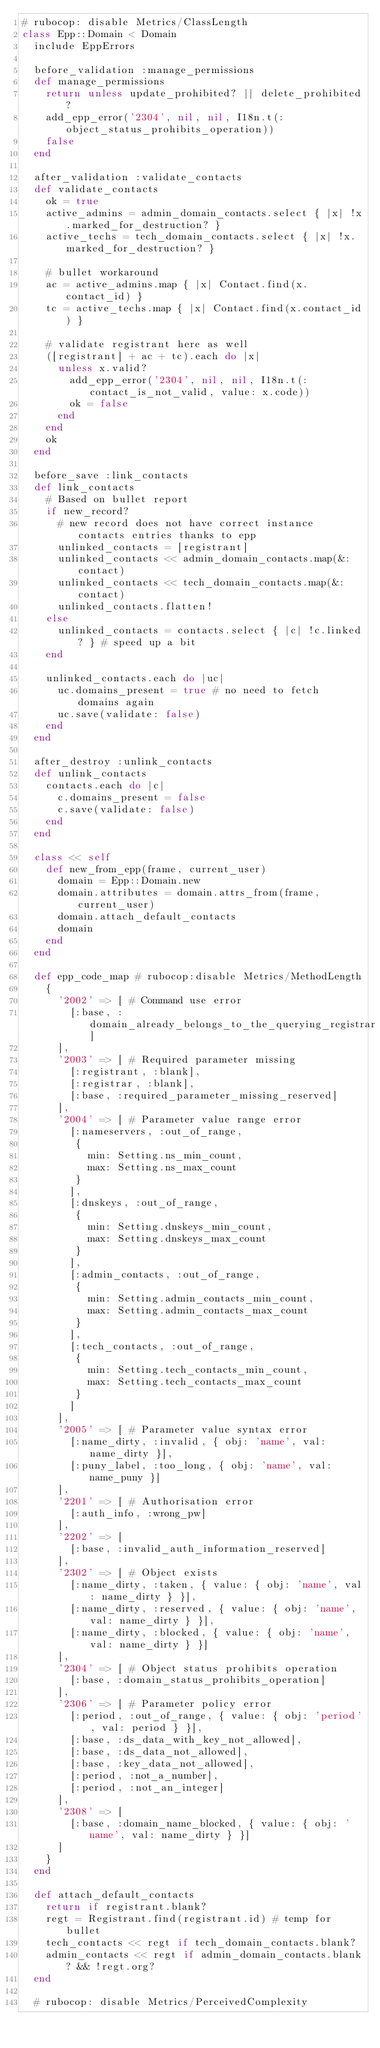Convert code to text. <code><loc_0><loc_0><loc_500><loc_500><_Ruby_># rubocop: disable Metrics/ClassLength
class Epp::Domain < Domain
  include EppErrors

  before_validation :manage_permissions
  def manage_permissions
    return unless update_prohibited? || delete_prohibited?
    add_epp_error('2304', nil, nil, I18n.t(:object_status_prohibits_operation))
    false
  end

  after_validation :validate_contacts
  def validate_contacts
    ok = true
    active_admins = admin_domain_contacts.select { |x| !x.marked_for_destruction? }
    active_techs = tech_domain_contacts.select { |x| !x.marked_for_destruction? }

    # bullet workaround
    ac = active_admins.map { |x| Contact.find(x.contact_id) }
    tc = active_techs.map { |x| Contact.find(x.contact_id) }

    # validate registrant here as well
    ([registrant] + ac + tc).each do |x|
      unless x.valid?
        add_epp_error('2304', nil, nil, I18n.t(:contact_is_not_valid, value: x.code))
        ok = false
      end
    end
    ok
  end

  before_save :link_contacts
  def link_contacts
    # Based on bullet report
    if new_record?
      # new record does not have correct instance contacts entries thanks to epp
      unlinked_contacts = [registrant]
      unlinked_contacts << admin_domain_contacts.map(&:contact)
      unlinked_contacts << tech_domain_contacts.map(&:contact)
      unlinked_contacts.flatten!
    else
      unlinked_contacts = contacts.select { |c| !c.linked? } # speed up a bit
    end

    unlinked_contacts.each do |uc|
      uc.domains_present = true # no need to fetch domains again
      uc.save(validate: false)
    end
  end

  after_destroy :unlink_contacts
  def unlink_contacts
    contacts.each do |c|
      c.domains_present = false
      c.save(validate: false)
    end
  end

  class << self
    def new_from_epp(frame, current_user)
      domain = Epp::Domain.new
      domain.attributes = domain.attrs_from(frame, current_user)
      domain.attach_default_contacts
      domain
    end
  end

  def epp_code_map # rubocop:disable Metrics/MethodLength
    {
      '2002' => [ # Command use error
        [:base, :domain_already_belongs_to_the_querying_registrar]
      ],
      '2003' => [ # Required parameter missing
        [:registrant, :blank],
        [:registrar, :blank],
        [:base, :required_parameter_missing_reserved]
      ],
      '2004' => [ # Parameter value range error
        [:nameservers, :out_of_range,
         {
           min: Setting.ns_min_count,
           max: Setting.ns_max_count
         }
        ],
        [:dnskeys, :out_of_range,
         {
           min: Setting.dnskeys_min_count,
           max: Setting.dnskeys_max_count
         }
        ],
        [:admin_contacts, :out_of_range,
         {
           min: Setting.admin_contacts_min_count,
           max: Setting.admin_contacts_max_count
         }
        ],
        [:tech_contacts, :out_of_range,
         {
           min: Setting.tech_contacts_min_count,
           max: Setting.tech_contacts_max_count
         }
        ]
      ],
      '2005' => [ # Parameter value syntax error
        [:name_dirty, :invalid, { obj: 'name', val: name_dirty }],
        [:puny_label, :too_long, { obj: 'name', val: name_puny }]
      ],
      '2201' => [ # Authorisation error
        [:auth_info, :wrong_pw]
      ],
      '2202' => [
        [:base, :invalid_auth_information_reserved]
      ],
      '2302' => [ # Object exists
        [:name_dirty, :taken, { value: { obj: 'name', val: name_dirty } }],
        [:name_dirty, :reserved, { value: { obj: 'name', val: name_dirty } }],
        [:name_dirty, :blocked, { value: { obj: 'name', val: name_dirty } }]
      ],
      '2304' => [ # Object status prohibits operation
        [:base, :domain_status_prohibits_operation]
      ],
      '2306' => [ # Parameter policy error
        [:period, :out_of_range, { value: { obj: 'period', val: period } }],
        [:base, :ds_data_with_key_not_allowed],
        [:base, :ds_data_not_allowed],
        [:base, :key_data_not_allowed],
        [:period, :not_a_number],
        [:period, :not_an_integer]
      ],
      '2308' => [
        [:base, :domain_name_blocked, { value: { obj: 'name', val: name_dirty } }]
      ]
    }
  end

  def attach_default_contacts
    return if registrant.blank?
    regt = Registrant.find(registrant.id) # temp for bullet
    tech_contacts << regt if tech_domain_contacts.blank?
    admin_contacts << regt if admin_domain_contacts.blank? && !regt.org?
  end

  # rubocop: disable Metrics/PerceivedComplexity</code> 